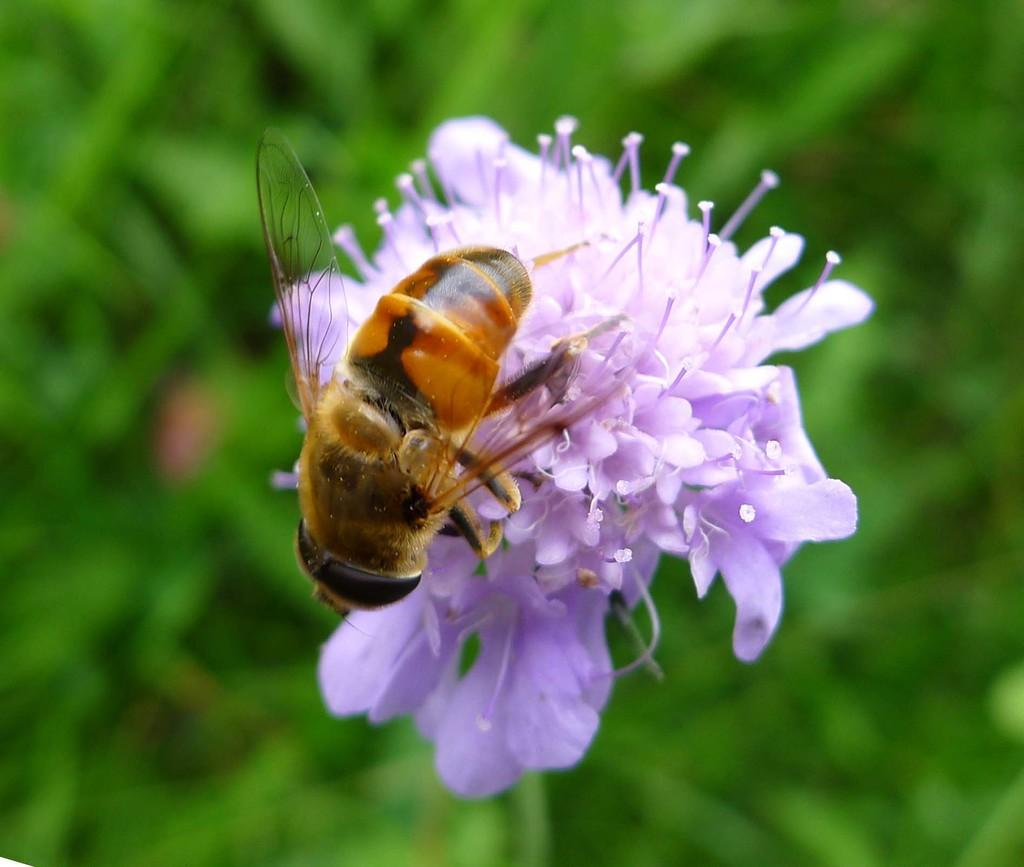What is present in the image? There is an insect in the image. What is the insect standing on? The insect is standing on a surface. Can you describe the surface the insect is on? The surface has light violet color flowers. How would you describe the background of the image? The background of the image is blurred. What type of polish is the fireman using on the book in the image? There is no fireman or book present in the image, so it's not possible to determine what type of polish might be used. 